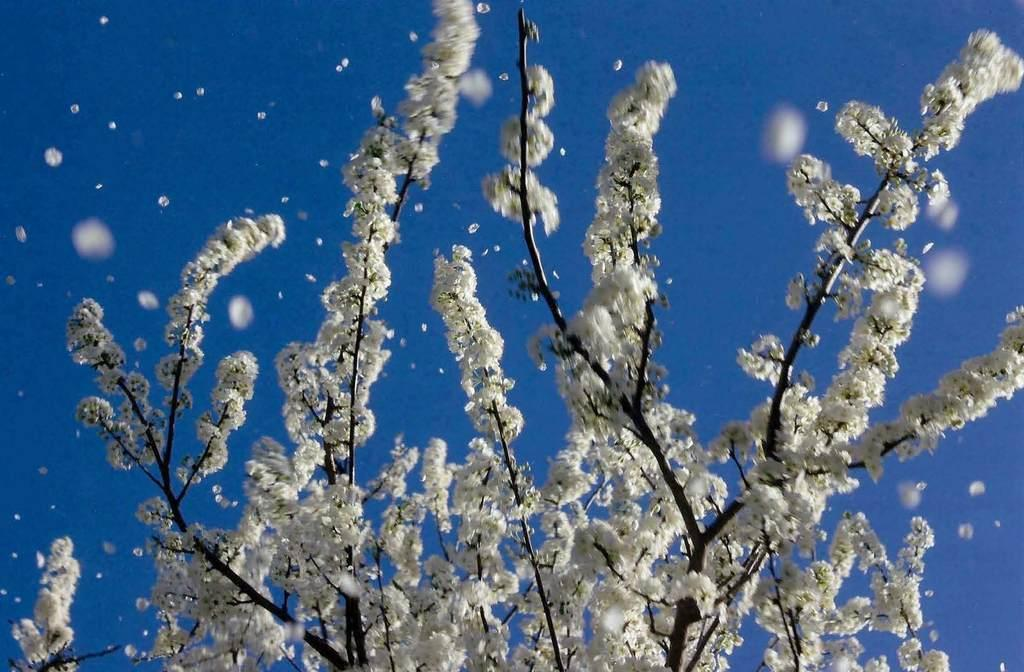What type of living organisms can be seen in the image? There are flowers in the image. What can be seen in the background of the image? The sky is visible in the background of the image. What type of hobbies do the dinosaurs in the image enjoy? There are no dinosaurs present in the image, so it is not possible to determine their hobbies. 